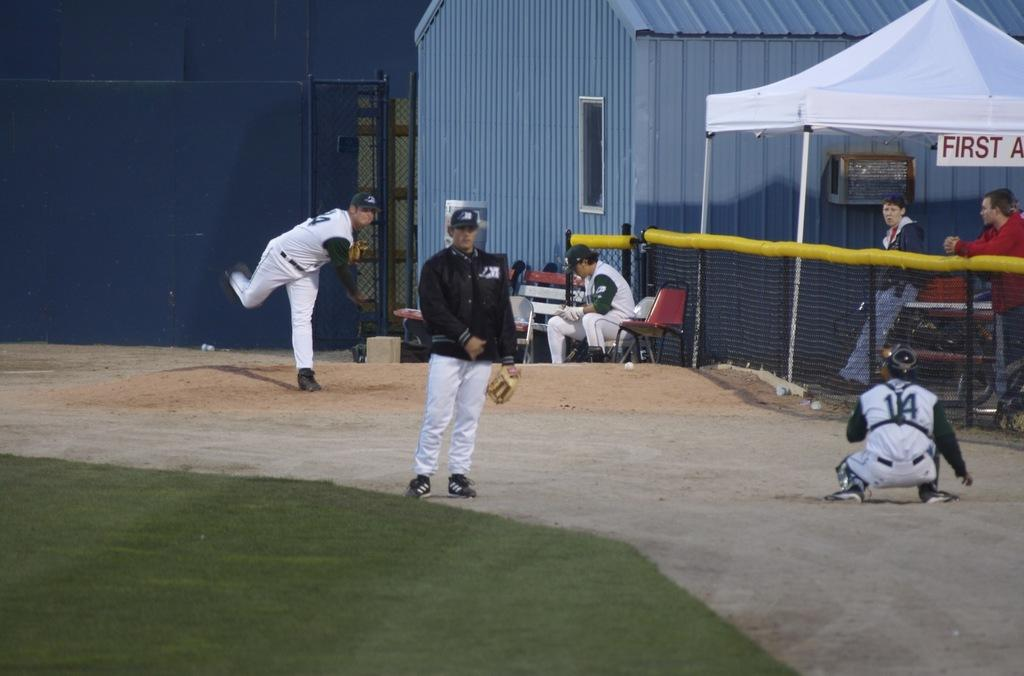Provide a one-sentence caption for the provided image. First aid tent set up next to a baseball field where players are practicing. 